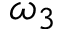Convert formula to latex. <formula><loc_0><loc_0><loc_500><loc_500>\omega _ { 3 }</formula> 